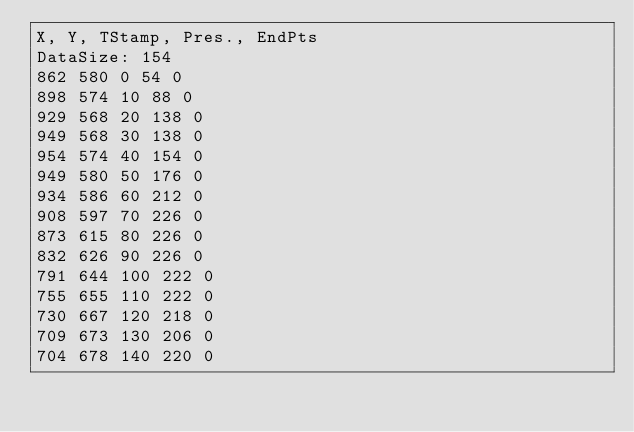Convert code to text. <code><loc_0><loc_0><loc_500><loc_500><_SML_>X, Y, TStamp, Pres., EndPts
DataSize: 154
862 580 0 54 0
898 574 10 88 0
929 568 20 138 0
949 568 30 138 0
954 574 40 154 0
949 580 50 176 0
934 586 60 212 0
908 597 70 226 0
873 615 80 226 0
832 626 90 226 0
791 644 100 222 0
755 655 110 222 0
730 667 120 218 0
709 673 130 206 0
704 678 140 220 0</code> 